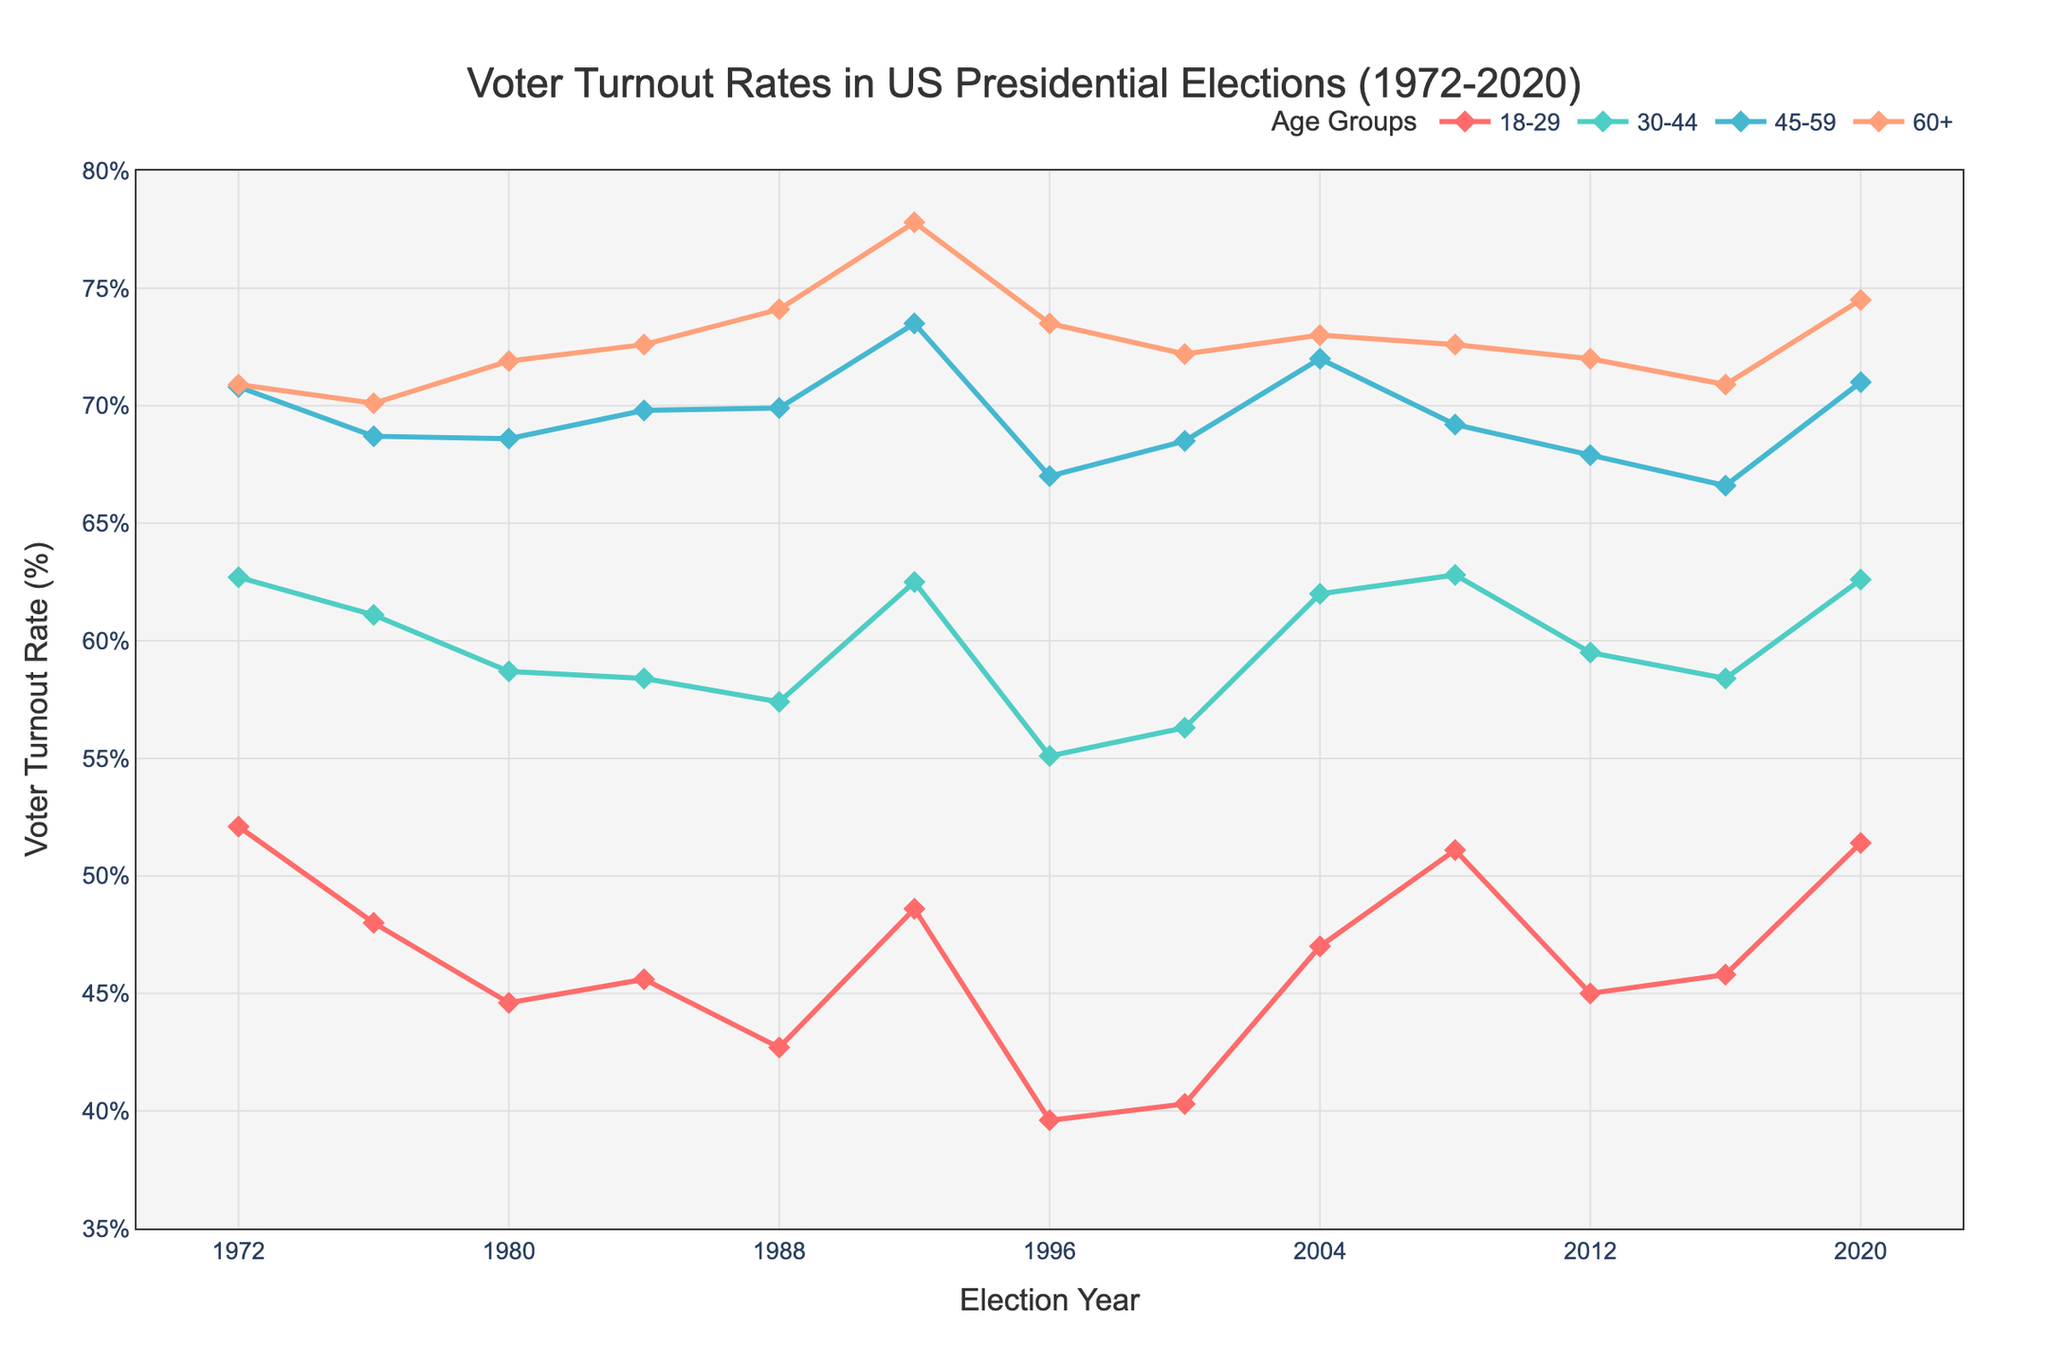What is the voter turnout rate for the 18-29 age group in 1988? Look at the data point on the line corresponding to the 18-29 age group for the year 1988 on the x-axis. Identify the y-value at that point.
Answer: 42.7% Which age group had the highest voter turnout rate in the 1992 election year? Look at the line chart to identify the highest y-value for the year 1992. This corresponds to the age group with the highest voter turnout in that year. The highest line at 1992 belongs to the '60+' age group.
Answer: 60+ How did the voter turnout rate for the 30-44 age group change from 2000 to 2008? Compare the y-values for the 30-44 age group in the years 2000 and 2008. Note the difference between these two rates.
Answer: Increased by 6.5% Which year had the lowest overall voter turnout rate for the 45-59 age group? Identify the lowest point on the line for the 45-59 age group across all years. The point with the lowest y-value will indicate the year with the lowest voter turnout rate.
Answer: 1996 What is the average voter turnout rate for the 60+ age group over all the years? Sum up the voter turnout rates for all the years for the 60+ age group and divide by the number of years (12). (70.9 + 70.1 + 71.9 + 72.6 + 74.1 + 77.8 + 73.5 + 72.2 + 73.0 + 72.6 + 72.0 + 70.9 + 74.5) / 12 = 890.1 / 12 = 74.2%
Answer: 74.2% By how much did the voter turnout rate for the 18-29 age group change from 1972 to 1996? Subtract the voter turnout rate in 1996 from the rate in 1972 for the 18-29 age group. 52.1% (1972) - 39.6% (1996) = 12.5%
Answer: Decreased by 12.5% Compare the voter turnout rates for the 30-44 and 45-59 age groups in 2004. Which age group had a higher rate and by how much? Identify the y-values for both age groups in 2004. Subtract the lower value from the higher value to find the difference. 72.0% (45-59) - 62.0% (30-44) = 10.0%
Answer: 45-59 by 10.0% Which age group showed the most consistent voter turnout rate (least fluctuations) over the period? Look at the line charts for each age group and visually assess which line has the least variation in height. This indicates the smallest changes in voter turnout rates.
Answer: 60+ What is the median voter turnout rate for the 30-44 age group across all the years? Arrange the voter turnout rates for the 30-44 age group in ascending order and find the middle value. If there is an even number of values, calculate the average of the two middle values. The rates are: 55.1, 56.3, 57.4, 58.4, 58.4, 58.7, 59.5, 61.1, 62.0, 62.5, 62.6, 62.7, 62.8. The two middle values are 58.7 and 59.5. (58.7 + 59.5) / 2 = 59.1%
Answer: 59.1% 